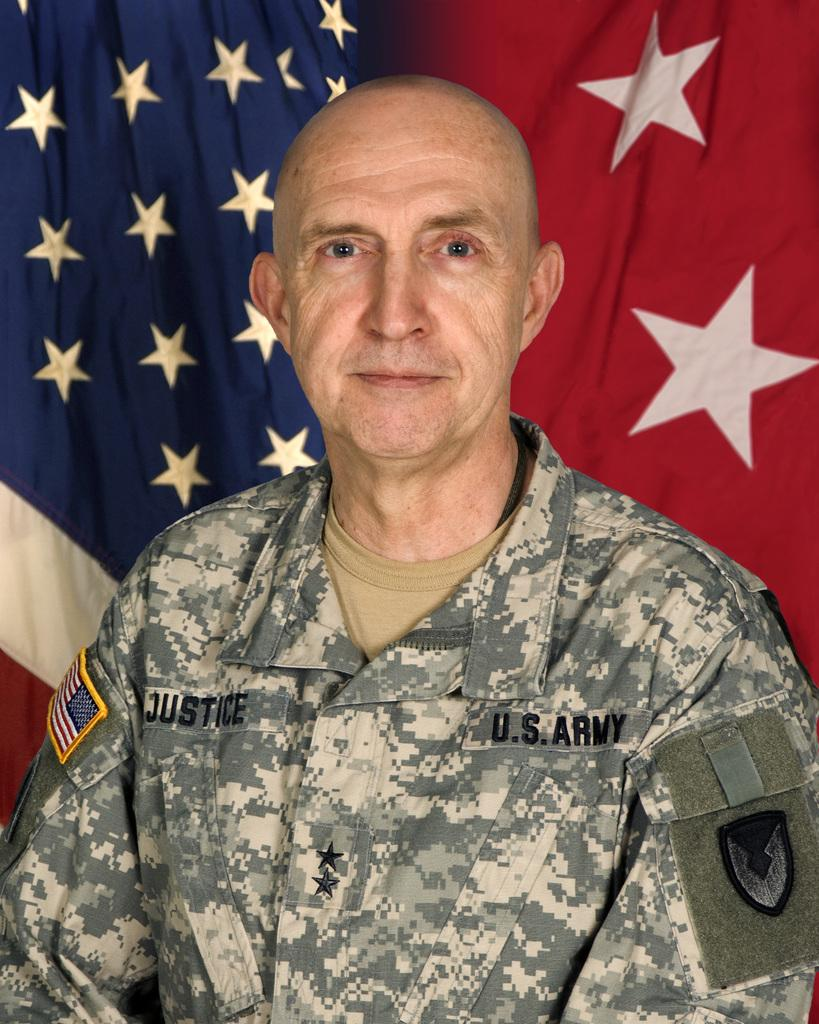Who or what is the main subject in the center of the image? There is a person in the center of the image. What is the person wearing? The person is wearing a uniform. What can be seen in the background of the image? There is a flag in the background of the image. How does the person in the image lift the heavy object using only air? There is no heavy object present in the image, and the person is not using air to lift anything. 